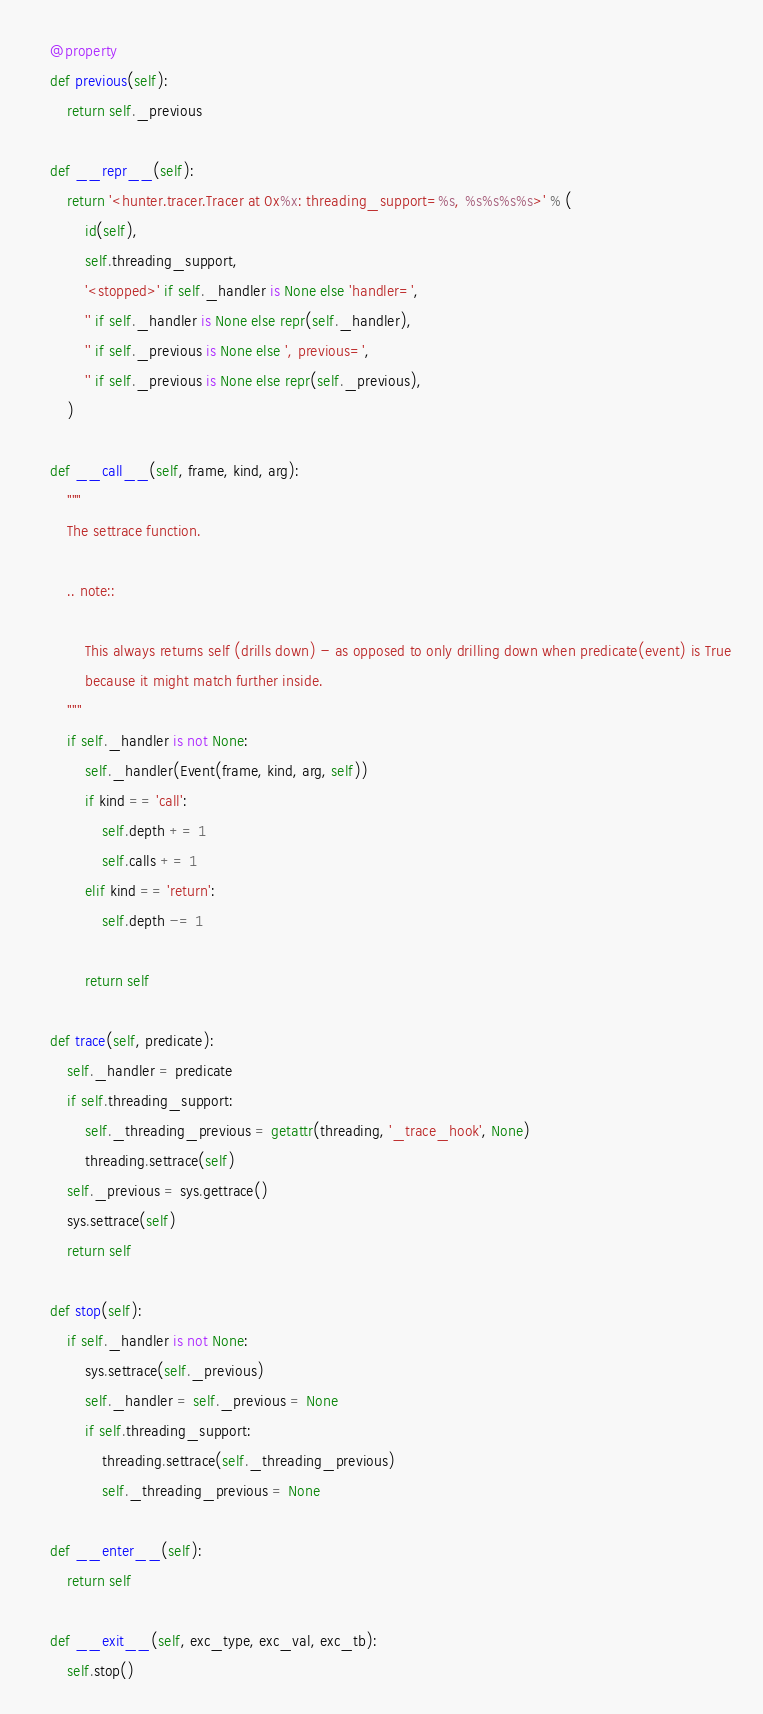<code> <loc_0><loc_0><loc_500><loc_500><_Python_>
    @property
    def previous(self):
        return self._previous

    def __repr__(self):
        return '<hunter.tracer.Tracer at 0x%x: threading_support=%s, %s%s%s%s>' % (
            id(self),
            self.threading_support,
            '<stopped>' if self._handler is None else 'handler=',
            '' if self._handler is None else repr(self._handler),
            '' if self._previous is None else ', previous=',
            '' if self._previous is None else repr(self._previous),
        )

    def __call__(self, frame, kind, arg):
        """
        The settrace function.

        .. note::

            This always returns self (drills down) - as opposed to only drilling down when predicate(event) is True
            because it might match further inside.
        """
        if self._handler is not None:
            self._handler(Event(frame, kind, arg, self))
            if kind == 'call':
                self.depth += 1
                self.calls += 1
            elif kind == 'return':
                self.depth -= 1

            return self

    def trace(self, predicate):
        self._handler = predicate
        if self.threading_support:
            self._threading_previous = getattr(threading, '_trace_hook', None)
            threading.settrace(self)
        self._previous = sys.gettrace()
        sys.settrace(self)
        return self

    def stop(self):
        if self._handler is not None:
            sys.settrace(self._previous)
            self._handler = self._previous = None
            if self.threading_support:
                threading.settrace(self._threading_previous)
                self._threading_previous = None

    def __enter__(self):
        return self

    def __exit__(self, exc_type, exc_val, exc_tb):
        self.stop()
</code> 